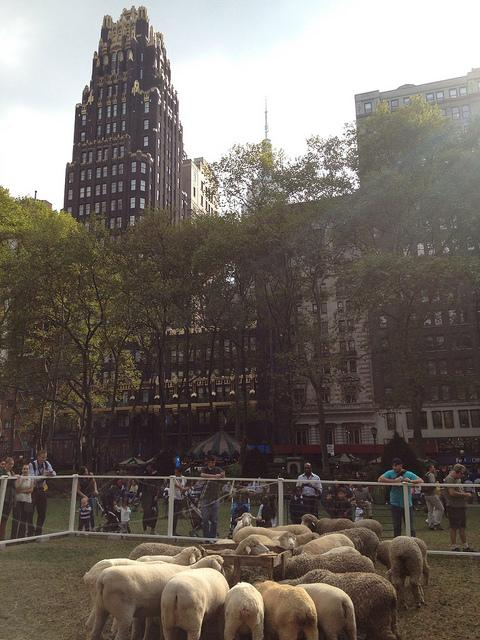What structure surrounds the animals? Please explain your reasoning. pen. A large fence is around some farm animals. many people are around the outer perimeter looking at them down in the city. 